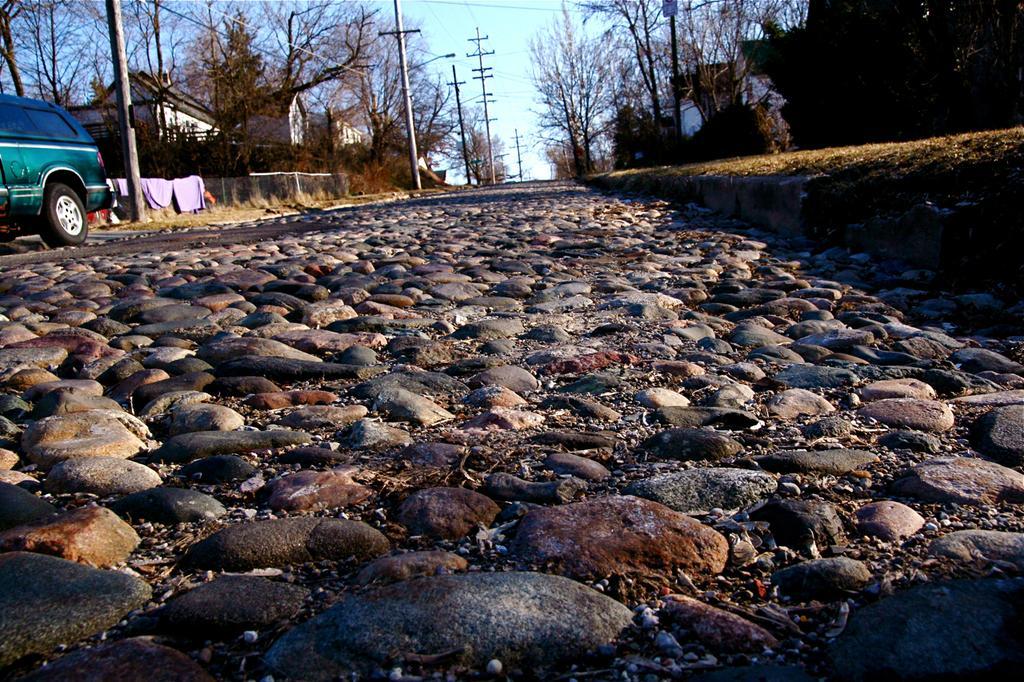In one or two sentences, can you explain what this image depicts? In this image I can see a road , on the road I can see stones visible and at the top I can see the sky , power line poles, houses , trees and wall , on the left side I can see a green color vehicle. 